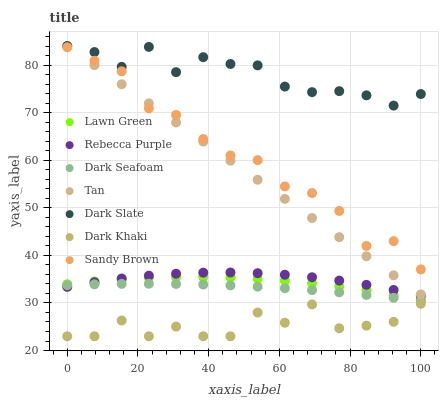Does Dark Khaki have the minimum area under the curve?
Answer yes or no. Yes. Does Dark Slate have the maximum area under the curve?
Answer yes or no. Yes. Does Dark Slate have the minimum area under the curve?
Answer yes or no. No. Does Dark Khaki have the maximum area under the curve?
Answer yes or no. No. Is Tan the smoothest?
Answer yes or no. Yes. Is Dark Khaki the roughest?
Answer yes or no. Yes. Is Dark Slate the smoothest?
Answer yes or no. No. Is Dark Slate the roughest?
Answer yes or no. No. Does Dark Khaki have the lowest value?
Answer yes or no. Yes. Does Dark Slate have the lowest value?
Answer yes or no. No. Does Tan have the highest value?
Answer yes or no. Yes. Does Dark Khaki have the highest value?
Answer yes or no. No. Is Dark Khaki less than Tan?
Answer yes or no. Yes. Is Tan greater than Rebecca Purple?
Answer yes or no. Yes. Does Dark Slate intersect Tan?
Answer yes or no. Yes. Is Dark Slate less than Tan?
Answer yes or no. No. Is Dark Slate greater than Tan?
Answer yes or no. No. Does Dark Khaki intersect Tan?
Answer yes or no. No. 